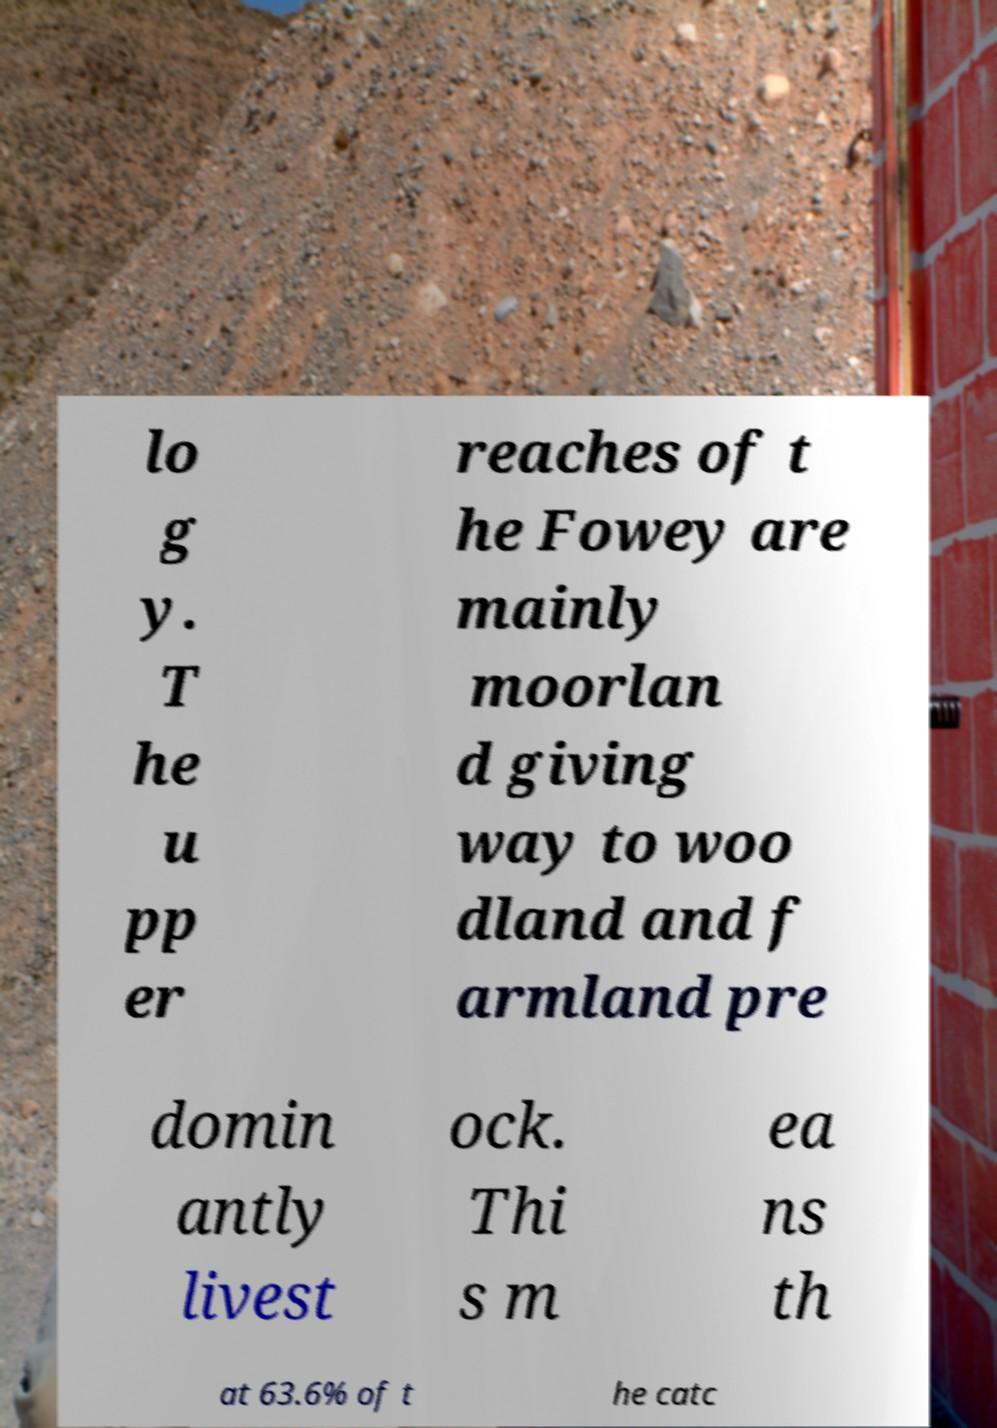Please identify and transcribe the text found in this image. lo g y. T he u pp er reaches of t he Fowey are mainly moorlan d giving way to woo dland and f armland pre domin antly livest ock. Thi s m ea ns th at 63.6% of t he catc 